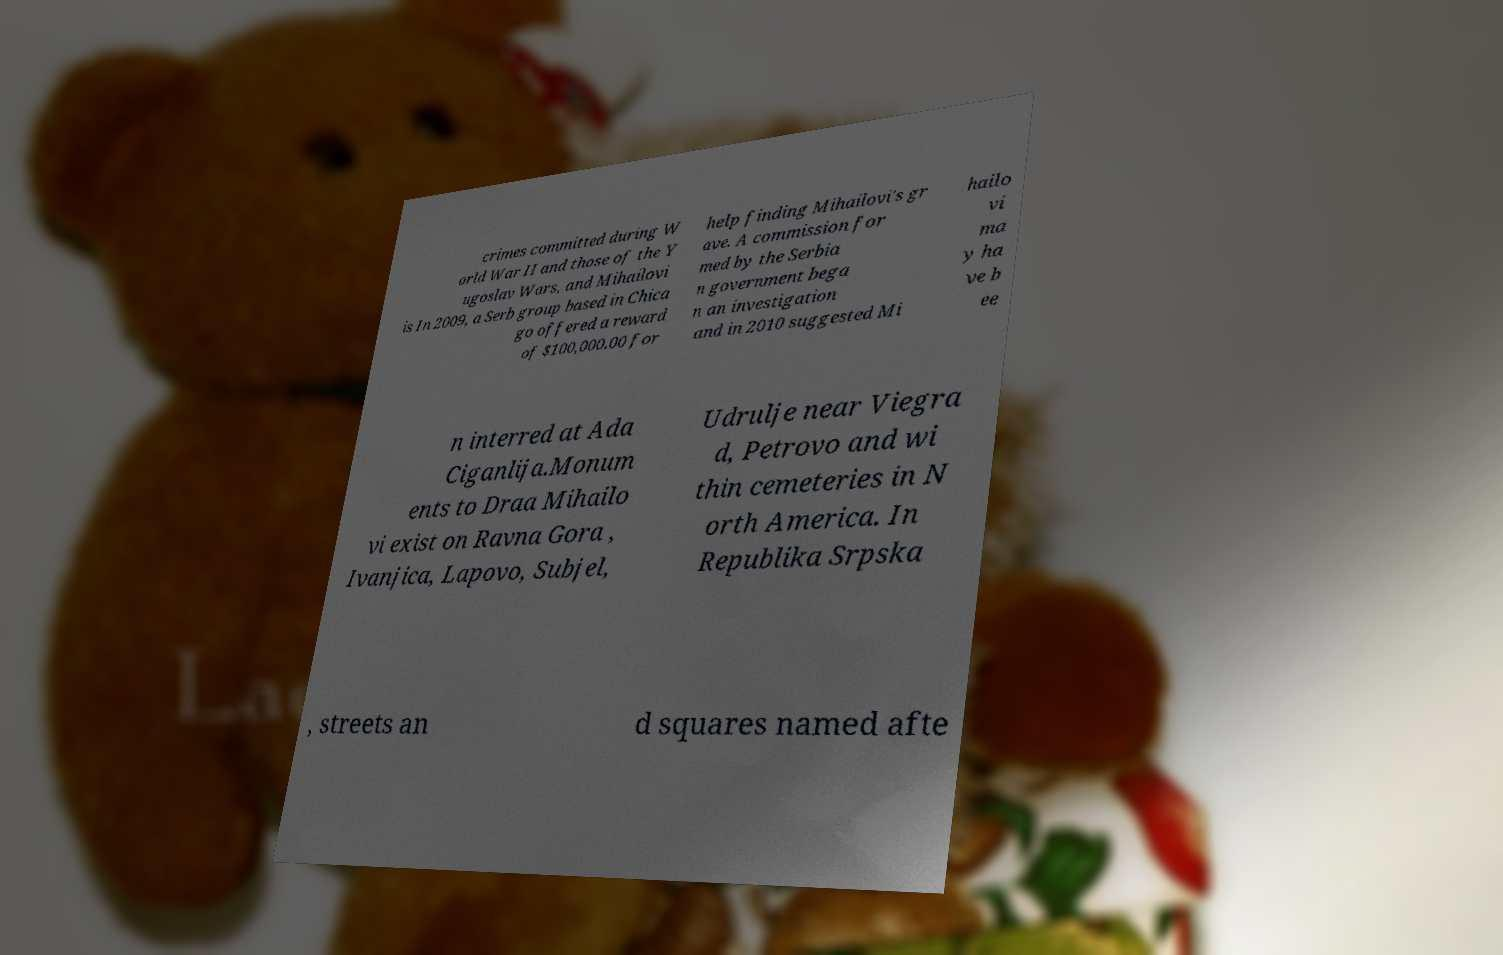There's text embedded in this image that I need extracted. Can you transcribe it verbatim? crimes committed during W orld War II and those of the Y ugoslav Wars, and Mihailovi is In 2009, a Serb group based in Chica go offered a reward of $100,000.00 for help finding Mihailovi's gr ave. A commission for med by the Serbia n government bega n an investigation and in 2010 suggested Mi hailo vi ma y ha ve b ee n interred at Ada Ciganlija.Monum ents to Draa Mihailo vi exist on Ravna Gora , Ivanjica, Lapovo, Subjel, Udrulje near Viegra d, Petrovo and wi thin cemeteries in N orth America. In Republika Srpska , streets an d squares named afte 